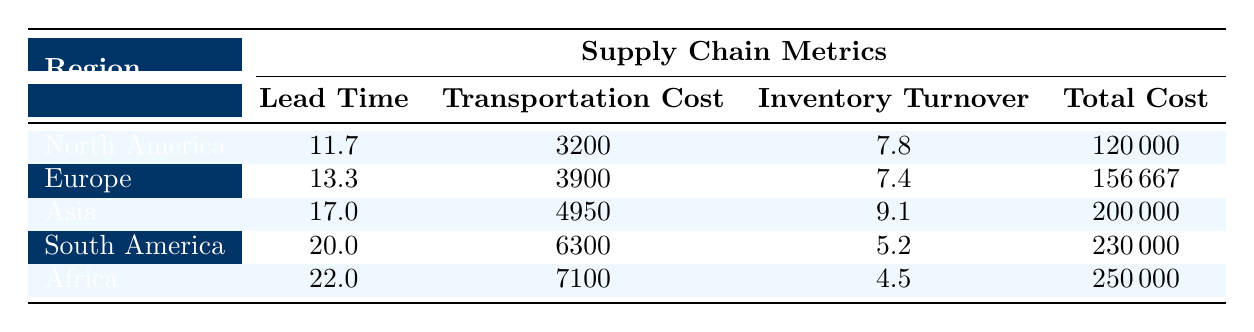What is the average lead time across all regions? To find the average lead time, add all the lead times together: (12 + 15 + 18 + 20 + 10 + 14 + 16 + 22) = 127. Then divide by the number of regions (8): 127 / 8 = 15.875. Rounding up, the average lead time is approximately 15.9.
Answer: 15.9 Which region has the highest total cost? Looking at the total costs in the table, compare them: North America = 120000, Europe = 156667, Asia = 200000, South America = 230000, and Africa = 250000. South America has the highest total cost at 230000.
Answer: South America What is the inventory turnover for Europe? In the table, under Europe, the inventory turnover is directly listed as 7.4. There are no calculations needed for this answer.
Answer: 7.4 Is the average transportation cost in Asia lower than in North America? First, calculate the average transportation cost for each region. North America (3200), Asia (4950). Compare: 4950 is greater than 3200, therefore, the average transportation cost in Asia is not lower than in North America.
Answer: No What is the difference between the highest and lowest inventory turnover rates? The highest inventory turnover rate is in Asia (9.1) and the lowest is in Africa (4.5). To find the difference, subtract the lowest from the highest: 9.1 - 4.5 = 4.6.
Answer: 4.6 Does North America have a low or medium tax incentive? The data shows that all suppliers in North America have a tax incentive classified as "Low." Therefore, the statement is accurate according to the information provided.
Answer: Low What is the total cost for suppliers in Europe? The total costs for European suppliers are 156667 (Siemens AG), 160000 (Robert Bosch GmbH), and 130000 (Continental AG). By adding these together: 156667 + 160000 + 130000 = 446667.
Answer: 446667 Which region has the longest lead time? The lead times listed are: North America (11.7), Europe (13.3), Asia (17.0), South America (20.0), and Africa (22.0). Comparing these values, Africa has the longest lead time at 22.0.
Answer: Africa What percentage of the total costs does Asia account for out of the combined total of all regions? The total costs for all regions are: 120000 (North America) + 156667 (Europe) + 200000 (Asia) + 230000 (South America) + 250000 (Africa) = 956667. Asia's total cost is 200000. To find the percentage, (200000 / 956667) * 100 = approximately 20.9%.
Answer: 20.9% 